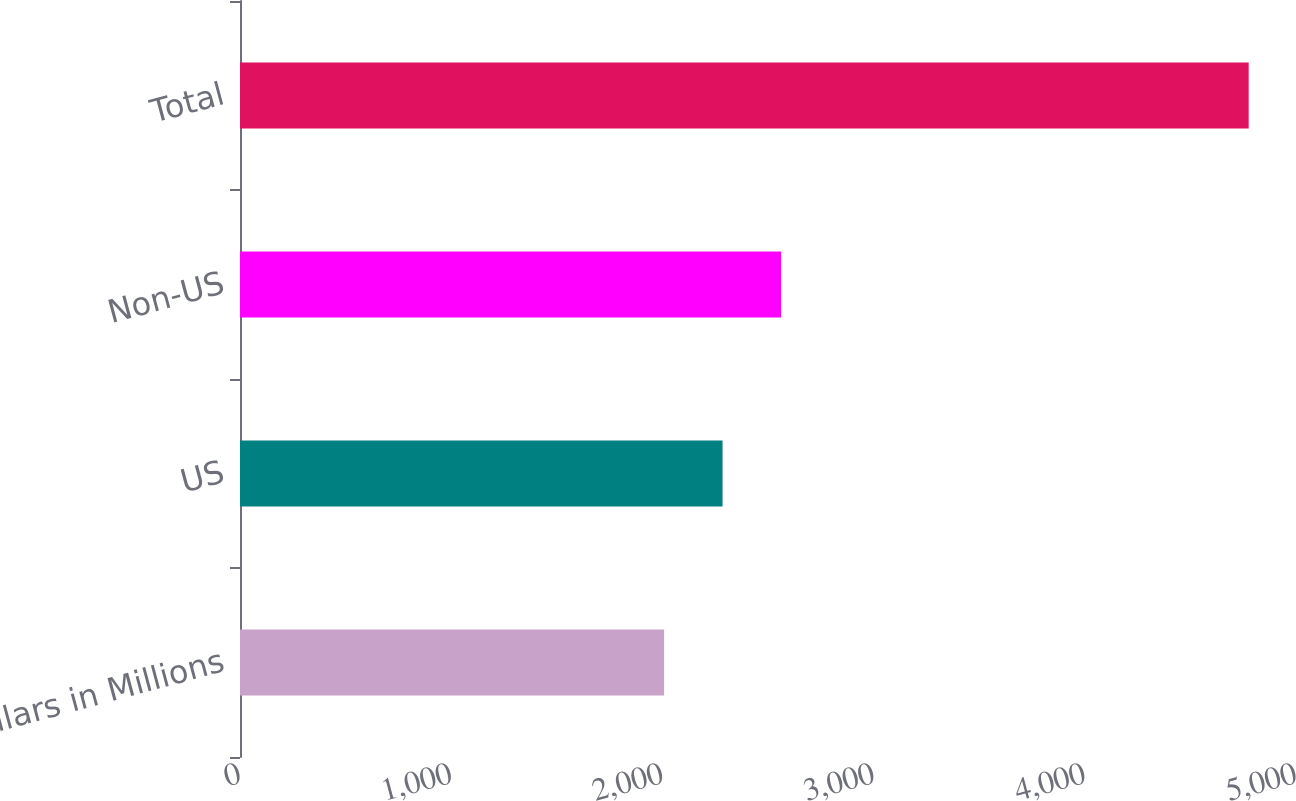Convert chart to OTSL. <chart><loc_0><loc_0><loc_500><loc_500><bar_chart><fcel>Dollars in Millions<fcel>US<fcel>Non-US<fcel>Total<nl><fcel>2008<fcel>2284.8<fcel>2561.6<fcel>4776<nl></chart> 